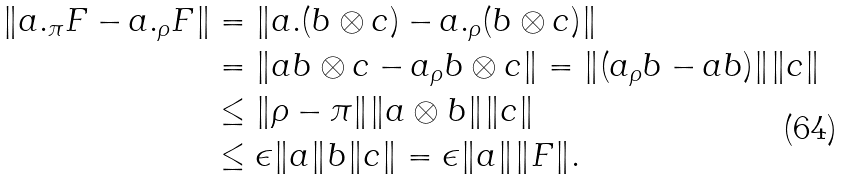Convert formula to latex. <formula><loc_0><loc_0><loc_500><loc_500>\| a . _ { \pi } F - a . _ { \rho } F \| & = \| a . ( b \otimes c ) - a . _ { \rho } ( b \otimes c ) \| \\ & = \| a b \otimes c - a _ { \rho } b \otimes c \| = \| ( a _ { \rho } b - a b ) \| \| c \| \\ & \leq \| \rho - \pi \| \| a \otimes b \| \| c \| \\ & \leq \epsilon \| a \| b \| c \| = \epsilon \| a \| \| F \| .</formula> 